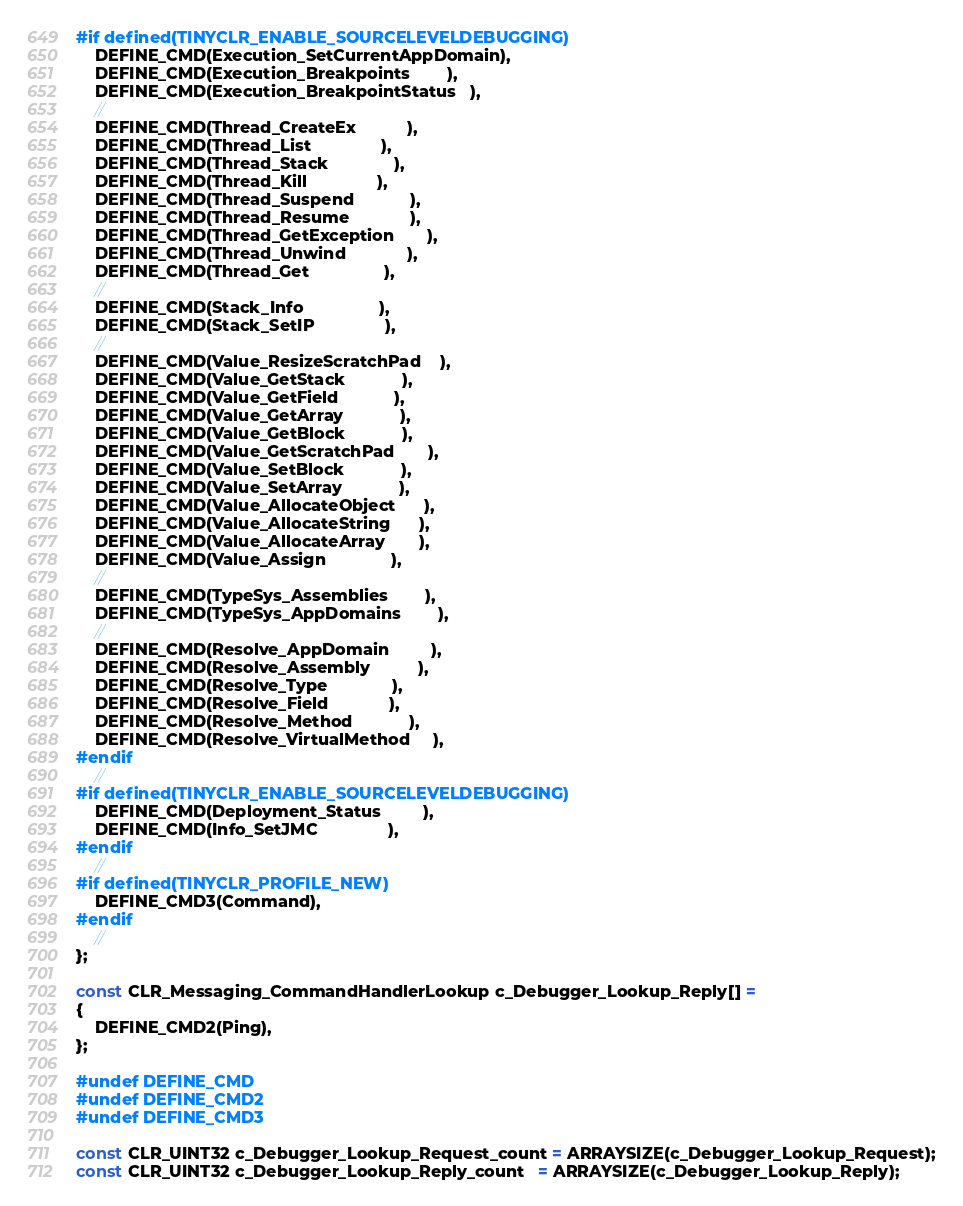Convert code to text. <code><loc_0><loc_0><loc_500><loc_500><_C++_>#if defined(TINYCLR_ENABLE_SOURCELEVELDEBUGGING)
    DEFINE_CMD(Execution_SetCurrentAppDomain),
    DEFINE_CMD(Execution_Breakpoints        ),
    DEFINE_CMD(Execution_BreakpointStatus   ),
    //
    DEFINE_CMD(Thread_CreateEx           ),
    DEFINE_CMD(Thread_List               ),
    DEFINE_CMD(Thread_Stack              ),
    DEFINE_CMD(Thread_Kill               ),
    DEFINE_CMD(Thread_Suspend            ),
    DEFINE_CMD(Thread_Resume             ),
    DEFINE_CMD(Thread_GetException       ),
    DEFINE_CMD(Thread_Unwind             ),
    DEFINE_CMD(Thread_Get                ),
    //
    DEFINE_CMD(Stack_Info                ),
    DEFINE_CMD(Stack_SetIP               ),
    //
    DEFINE_CMD(Value_ResizeScratchPad    ),
    DEFINE_CMD(Value_GetStack            ),
    DEFINE_CMD(Value_GetField            ),
    DEFINE_CMD(Value_GetArray            ),
    DEFINE_CMD(Value_GetBlock            ),
    DEFINE_CMD(Value_GetScratchPad       ),
    DEFINE_CMD(Value_SetBlock            ),
    DEFINE_CMD(Value_SetArray            ),
    DEFINE_CMD(Value_AllocateObject      ),
    DEFINE_CMD(Value_AllocateString      ),
    DEFINE_CMD(Value_AllocateArray       ),
    DEFINE_CMD(Value_Assign              ),
    //
    DEFINE_CMD(TypeSys_Assemblies        ),
    DEFINE_CMD(TypeSys_AppDomains        ),
    //
    DEFINE_CMD(Resolve_AppDomain         ),
    DEFINE_CMD(Resolve_Assembly          ),
    DEFINE_CMD(Resolve_Type              ),
    DEFINE_CMD(Resolve_Field             ),
    DEFINE_CMD(Resolve_Method            ),
    DEFINE_CMD(Resolve_VirtualMethod     ),
#endif
    //
#if defined(TINYCLR_ENABLE_SOURCELEVELDEBUGGING)
    DEFINE_CMD(Deployment_Status         ),
    DEFINE_CMD(Info_SetJMC               ),
#endif    
    //
#if defined(TINYCLR_PROFILE_NEW)
    DEFINE_CMD3(Command),
#endif
    //
};

const CLR_Messaging_CommandHandlerLookup c_Debugger_Lookup_Reply[] =
{
    DEFINE_CMD2(Ping),
};

#undef DEFINE_CMD
#undef DEFINE_CMD2
#undef DEFINE_CMD3

const CLR_UINT32 c_Debugger_Lookup_Request_count = ARRAYSIZE(c_Debugger_Lookup_Request);
const CLR_UINT32 c_Debugger_Lookup_Reply_count   = ARRAYSIZE(c_Debugger_Lookup_Reply);

</code> 